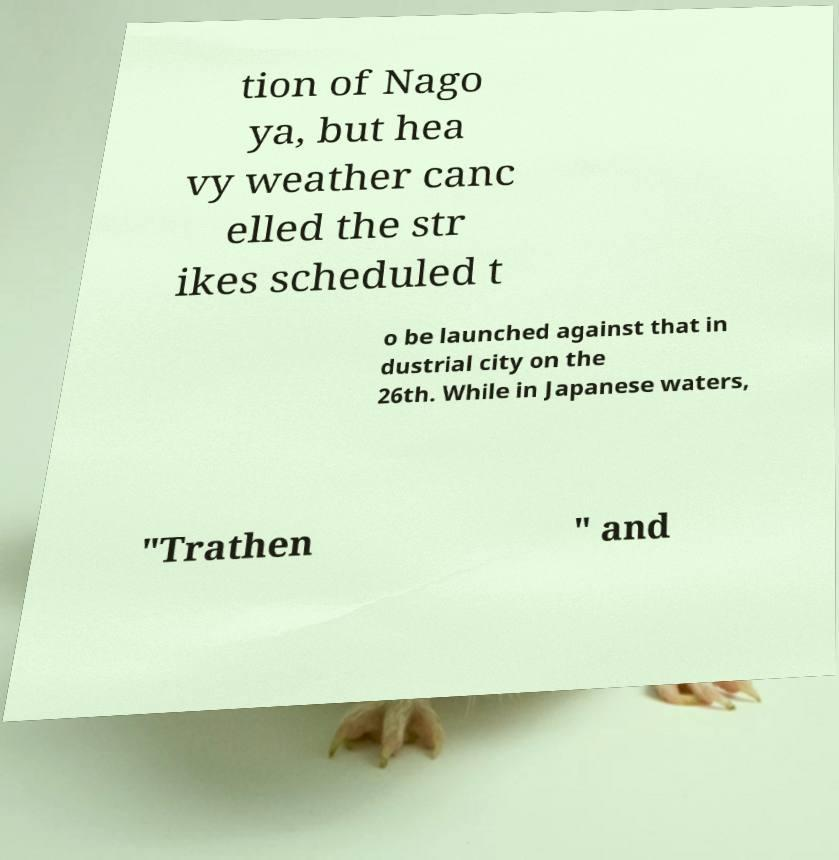Can you accurately transcribe the text from the provided image for me? tion of Nago ya, but hea vy weather canc elled the str ikes scheduled t o be launched against that in dustrial city on the 26th. While in Japanese waters, "Trathen " and 